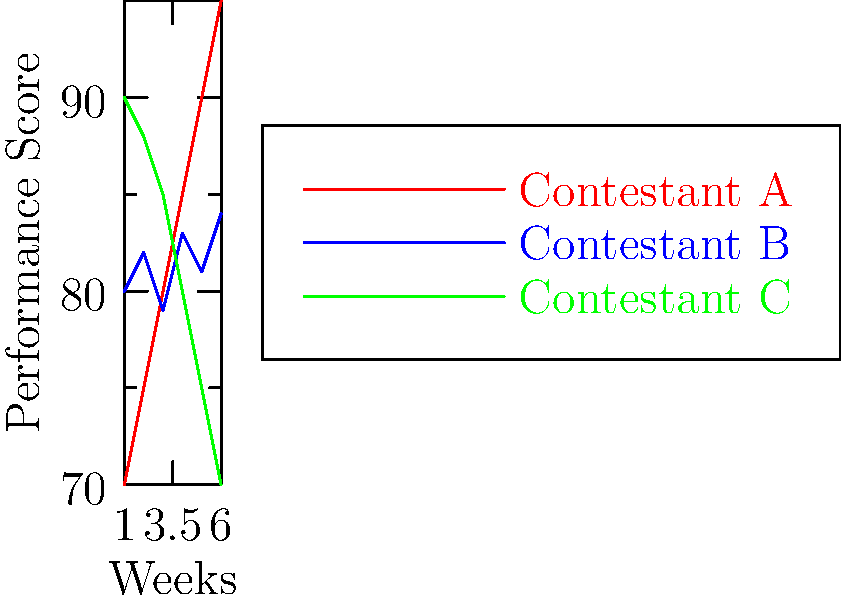Based on the performance graphs of three X Factor contestants over six weeks, which contestant is most likely to win the competition? To predict the likely winner of The X Factor based on these performance graphs, we need to analyze the trends for each contestant:

1. Contestant A (red line):
   - Started with the lowest score of 70 in week 1
   - Shows a consistent upward trend each week
   - Ends with the highest score of 95 in week 6
   - Demonstrates significant improvement and growth

2. Contestant B (blue line):
   - Started with a score of 80 in week 1
   - Shows slight fluctuations but maintains a relatively stable performance
   - Ends with a score of 84 in week 6
   - Demonstrates consistency but less growth than Contestant A

3. Contestant C (green line):
   - Started with the highest score of 90 in week 1
   - Shows a consistent downward trend each week
   - Ends with the lowest score of 70 in week 6
   - Demonstrates declining performance over time

Analyzing these trends, Contestant A is most likely to win the competition for the following reasons:
1. They show the most significant improvement over time
2. They end with the highest score in the final week
3. Their upward trajectory suggests they are peaking at the right time

In reality, other factors like song choice, stage presence, and audience voting also play a role. However, based solely on these performance graphs, Contestant A appears to be the frontrunner.
Answer: Contestant A 